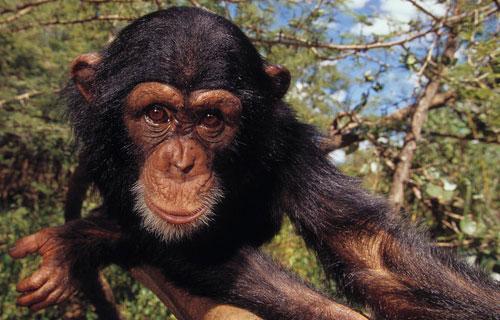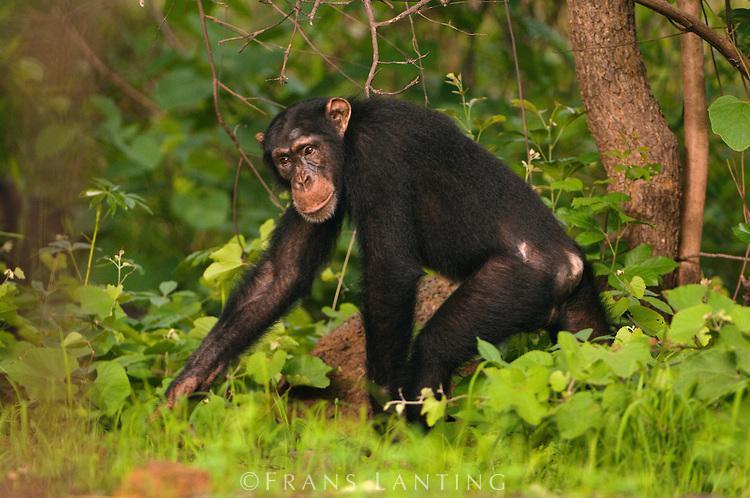The first image is the image on the left, the second image is the image on the right. For the images shown, is this caption "The right image contains exactly one chimpanzee." true? Answer yes or no. Yes. The first image is the image on the left, the second image is the image on the right. Given the left and right images, does the statement "One image includes exactly twice as many chimps as the other image." hold true? Answer yes or no. No. 